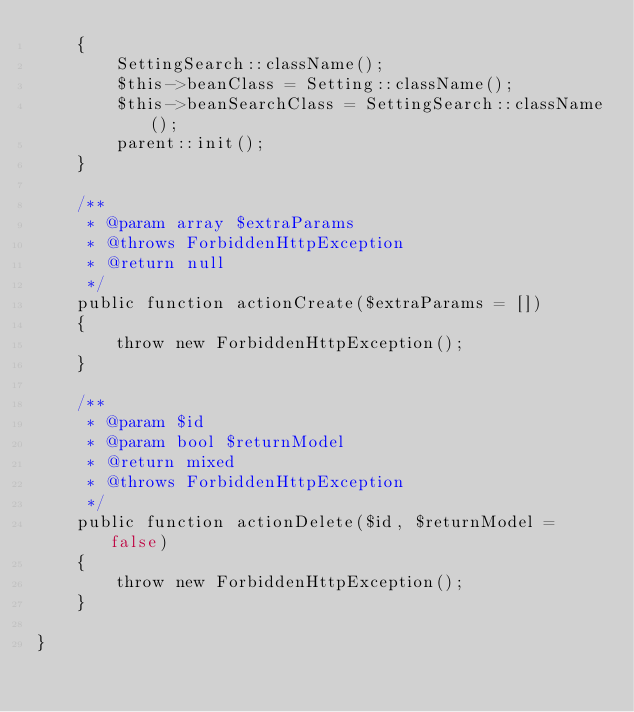<code> <loc_0><loc_0><loc_500><loc_500><_PHP_>    {
        SettingSearch::className();
        $this->beanClass = Setting::className();
        $this->beanSearchClass = SettingSearch::className();
        parent::init();
    }

    /**
     * @param array $extraParams
     * @throws ForbiddenHttpException
     * @return null
     */
    public function actionCreate($extraParams = [])
    {
        throw new ForbiddenHttpException();
    }

    /**
     * @param $id
     * @param bool $returnModel
     * @return mixed
     * @throws ForbiddenHttpException
     */
    public function actionDelete($id, $returnModel = false)
    {
        throw new ForbiddenHttpException();
    }

}
</code> 